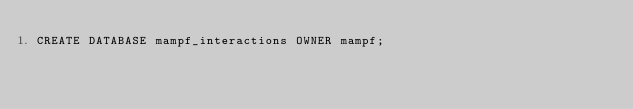<code> <loc_0><loc_0><loc_500><loc_500><_SQL_>CREATE DATABASE mampf_interactions OWNER mampf;</code> 